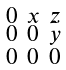Convert formula to latex. <formula><loc_0><loc_0><loc_500><loc_500>\begin{smallmatrix} 0 & x & z \\ 0 & 0 & y \\ 0 & 0 & 0 \end{smallmatrix}</formula> 